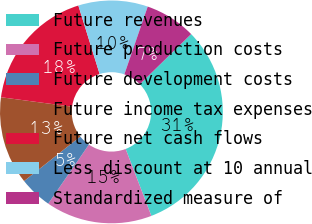Convert chart to OTSL. <chart><loc_0><loc_0><loc_500><loc_500><pie_chart><fcel>Future revenues<fcel>Future production costs<fcel>Future development costs<fcel>Future income tax expenses<fcel>Future net cash flows<fcel>Less discount at 10 annual<fcel>Standardized measure of<nl><fcel>31.47%<fcel>15.43%<fcel>4.74%<fcel>12.76%<fcel>18.1%<fcel>10.08%<fcel>7.41%<nl></chart> 